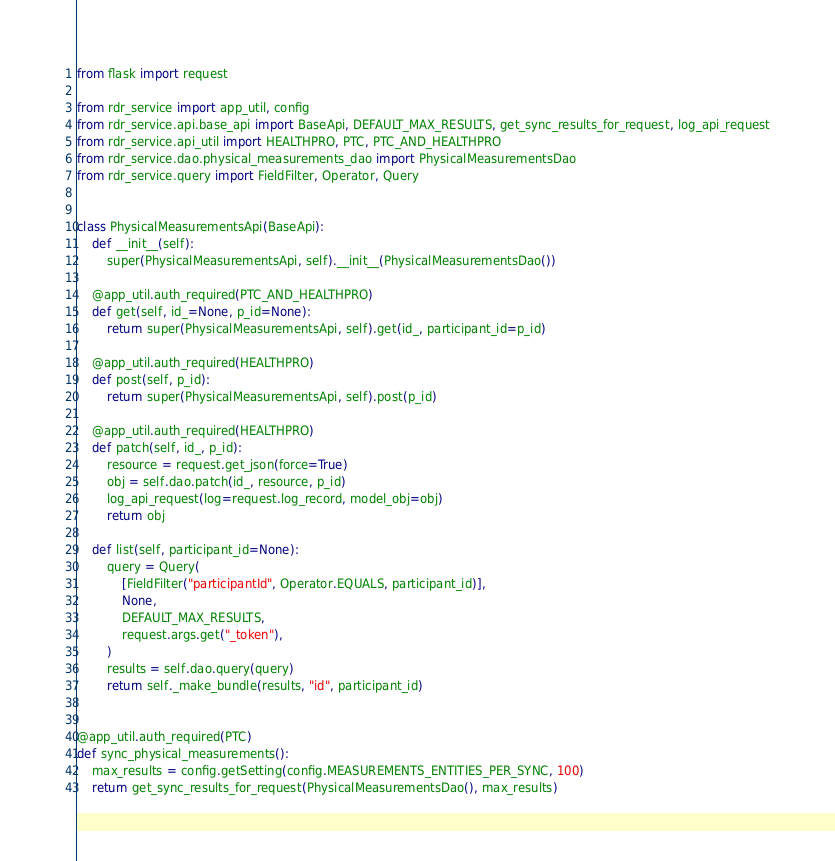Convert code to text. <code><loc_0><loc_0><loc_500><loc_500><_Python_>from flask import request

from rdr_service import app_util, config
from rdr_service.api.base_api import BaseApi, DEFAULT_MAX_RESULTS, get_sync_results_for_request, log_api_request
from rdr_service.api_util import HEALTHPRO, PTC, PTC_AND_HEALTHPRO
from rdr_service.dao.physical_measurements_dao import PhysicalMeasurementsDao
from rdr_service.query import FieldFilter, Operator, Query


class PhysicalMeasurementsApi(BaseApi):
    def __init__(self):
        super(PhysicalMeasurementsApi, self).__init__(PhysicalMeasurementsDao())

    @app_util.auth_required(PTC_AND_HEALTHPRO)
    def get(self, id_=None, p_id=None):
        return super(PhysicalMeasurementsApi, self).get(id_, participant_id=p_id)

    @app_util.auth_required(HEALTHPRO)
    def post(self, p_id):
        return super(PhysicalMeasurementsApi, self).post(p_id)

    @app_util.auth_required(HEALTHPRO)
    def patch(self, id_, p_id):
        resource = request.get_json(force=True)
        obj = self.dao.patch(id_, resource, p_id)
        log_api_request(log=request.log_record, model_obj=obj)
        return obj

    def list(self, participant_id=None):
        query = Query(
            [FieldFilter("participantId", Operator.EQUALS, participant_id)],
            None,
            DEFAULT_MAX_RESULTS,
            request.args.get("_token"),
        )
        results = self.dao.query(query)
        return self._make_bundle(results, "id", participant_id)


@app_util.auth_required(PTC)
def sync_physical_measurements():
    max_results = config.getSetting(config.MEASUREMENTS_ENTITIES_PER_SYNC, 100)
    return get_sync_results_for_request(PhysicalMeasurementsDao(), max_results)
</code> 